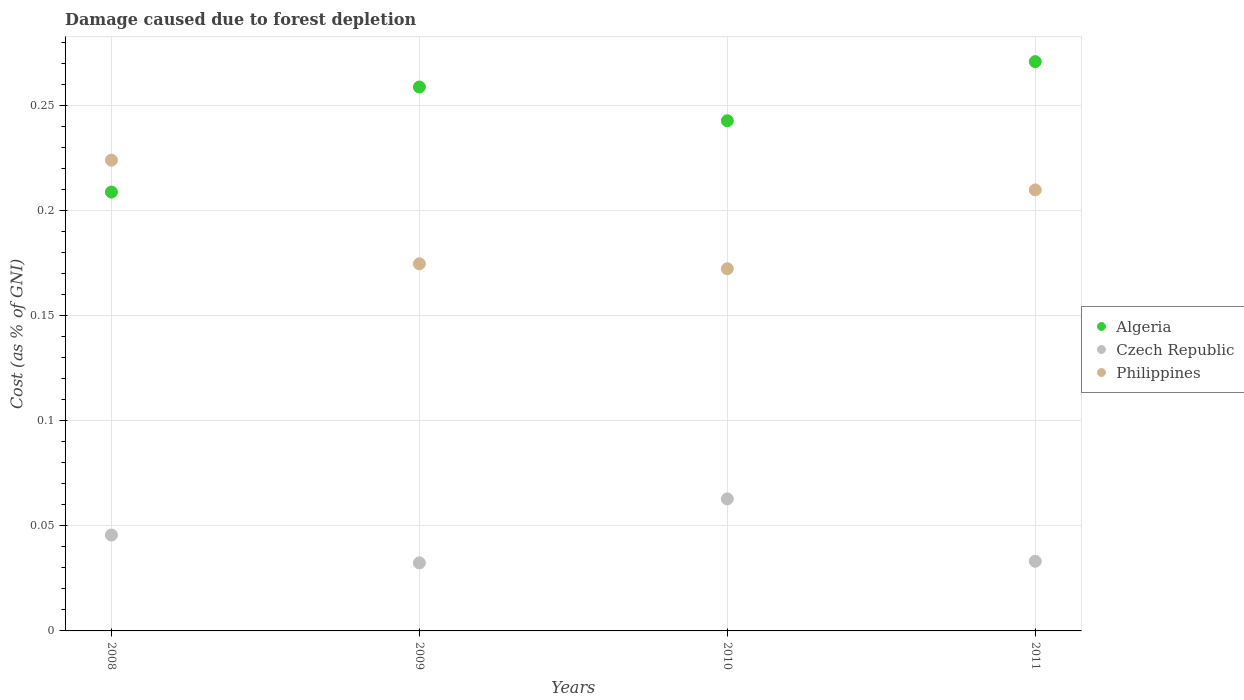How many different coloured dotlines are there?
Make the answer very short. 3. What is the cost of damage caused due to forest depletion in Algeria in 2010?
Your answer should be very brief. 0.24. Across all years, what is the maximum cost of damage caused due to forest depletion in Philippines?
Ensure brevity in your answer.  0.22. Across all years, what is the minimum cost of damage caused due to forest depletion in Algeria?
Offer a terse response. 0.21. In which year was the cost of damage caused due to forest depletion in Algeria maximum?
Provide a succinct answer. 2011. What is the total cost of damage caused due to forest depletion in Algeria in the graph?
Your answer should be very brief. 0.98. What is the difference between the cost of damage caused due to forest depletion in Algeria in 2009 and that in 2010?
Provide a short and direct response. 0.02. What is the difference between the cost of damage caused due to forest depletion in Czech Republic in 2009 and the cost of damage caused due to forest depletion in Philippines in 2010?
Offer a terse response. -0.14. What is the average cost of damage caused due to forest depletion in Czech Republic per year?
Offer a very short reply. 0.04. In the year 2010, what is the difference between the cost of damage caused due to forest depletion in Algeria and cost of damage caused due to forest depletion in Czech Republic?
Provide a succinct answer. 0.18. In how many years, is the cost of damage caused due to forest depletion in Czech Republic greater than 0.26 %?
Keep it short and to the point. 0. What is the ratio of the cost of damage caused due to forest depletion in Philippines in 2010 to that in 2011?
Your answer should be very brief. 0.82. Is the cost of damage caused due to forest depletion in Czech Republic in 2009 less than that in 2010?
Provide a succinct answer. Yes. Is the difference between the cost of damage caused due to forest depletion in Algeria in 2009 and 2011 greater than the difference between the cost of damage caused due to forest depletion in Czech Republic in 2009 and 2011?
Your answer should be compact. No. What is the difference between the highest and the second highest cost of damage caused due to forest depletion in Czech Republic?
Offer a terse response. 0.02. What is the difference between the highest and the lowest cost of damage caused due to forest depletion in Philippines?
Your answer should be very brief. 0.05. Is the sum of the cost of damage caused due to forest depletion in Philippines in 2009 and 2011 greater than the maximum cost of damage caused due to forest depletion in Algeria across all years?
Keep it short and to the point. Yes. Is it the case that in every year, the sum of the cost of damage caused due to forest depletion in Philippines and cost of damage caused due to forest depletion in Czech Republic  is greater than the cost of damage caused due to forest depletion in Algeria?
Keep it short and to the point. No. Does the cost of damage caused due to forest depletion in Czech Republic monotonically increase over the years?
Offer a terse response. No. How many dotlines are there?
Give a very brief answer. 3. How many years are there in the graph?
Give a very brief answer. 4. What is the difference between two consecutive major ticks on the Y-axis?
Your answer should be compact. 0.05. Are the values on the major ticks of Y-axis written in scientific E-notation?
Give a very brief answer. No. Does the graph contain grids?
Provide a succinct answer. Yes. Where does the legend appear in the graph?
Make the answer very short. Center right. What is the title of the graph?
Your response must be concise. Damage caused due to forest depletion. Does "Puerto Rico" appear as one of the legend labels in the graph?
Your response must be concise. No. What is the label or title of the X-axis?
Keep it short and to the point. Years. What is the label or title of the Y-axis?
Your answer should be very brief. Cost (as % of GNI). What is the Cost (as % of GNI) of Algeria in 2008?
Ensure brevity in your answer.  0.21. What is the Cost (as % of GNI) of Czech Republic in 2008?
Your answer should be compact. 0.05. What is the Cost (as % of GNI) in Philippines in 2008?
Provide a short and direct response. 0.22. What is the Cost (as % of GNI) of Algeria in 2009?
Your response must be concise. 0.26. What is the Cost (as % of GNI) of Czech Republic in 2009?
Provide a succinct answer. 0.03. What is the Cost (as % of GNI) in Philippines in 2009?
Provide a succinct answer. 0.17. What is the Cost (as % of GNI) of Algeria in 2010?
Provide a short and direct response. 0.24. What is the Cost (as % of GNI) in Czech Republic in 2010?
Your answer should be compact. 0.06. What is the Cost (as % of GNI) of Philippines in 2010?
Provide a succinct answer. 0.17. What is the Cost (as % of GNI) of Algeria in 2011?
Your answer should be compact. 0.27. What is the Cost (as % of GNI) in Czech Republic in 2011?
Your answer should be very brief. 0.03. What is the Cost (as % of GNI) of Philippines in 2011?
Your response must be concise. 0.21. Across all years, what is the maximum Cost (as % of GNI) in Algeria?
Offer a terse response. 0.27. Across all years, what is the maximum Cost (as % of GNI) in Czech Republic?
Your answer should be compact. 0.06. Across all years, what is the maximum Cost (as % of GNI) in Philippines?
Make the answer very short. 0.22. Across all years, what is the minimum Cost (as % of GNI) of Algeria?
Your answer should be compact. 0.21. Across all years, what is the minimum Cost (as % of GNI) in Czech Republic?
Your answer should be compact. 0.03. Across all years, what is the minimum Cost (as % of GNI) of Philippines?
Offer a very short reply. 0.17. What is the total Cost (as % of GNI) in Algeria in the graph?
Provide a short and direct response. 0.98. What is the total Cost (as % of GNI) in Czech Republic in the graph?
Ensure brevity in your answer.  0.17. What is the total Cost (as % of GNI) of Philippines in the graph?
Provide a succinct answer. 0.78. What is the difference between the Cost (as % of GNI) in Czech Republic in 2008 and that in 2009?
Your response must be concise. 0.01. What is the difference between the Cost (as % of GNI) in Philippines in 2008 and that in 2009?
Your response must be concise. 0.05. What is the difference between the Cost (as % of GNI) in Algeria in 2008 and that in 2010?
Make the answer very short. -0.03. What is the difference between the Cost (as % of GNI) of Czech Republic in 2008 and that in 2010?
Offer a terse response. -0.02. What is the difference between the Cost (as % of GNI) of Philippines in 2008 and that in 2010?
Offer a terse response. 0.05. What is the difference between the Cost (as % of GNI) of Algeria in 2008 and that in 2011?
Your answer should be very brief. -0.06. What is the difference between the Cost (as % of GNI) in Czech Republic in 2008 and that in 2011?
Ensure brevity in your answer.  0.01. What is the difference between the Cost (as % of GNI) in Philippines in 2008 and that in 2011?
Provide a short and direct response. 0.01. What is the difference between the Cost (as % of GNI) of Algeria in 2009 and that in 2010?
Your answer should be compact. 0.02. What is the difference between the Cost (as % of GNI) of Czech Republic in 2009 and that in 2010?
Provide a short and direct response. -0.03. What is the difference between the Cost (as % of GNI) of Philippines in 2009 and that in 2010?
Your answer should be very brief. 0. What is the difference between the Cost (as % of GNI) of Algeria in 2009 and that in 2011?
Offer a very short reply. -0.01. What is the difference between the Cost (as % of GNI) in Czech Republic in 2009 and that in 2011?
Offer a terse response. -0. What is the difference between the Cost (as % of GNI) in Philippines in 2009 and that in 2011?
Make the answer very short. -0.04. What is the difference between the Cost (as % of GNI) in Algeria in 2010 and that in 2011?
Give a very brief answer. -0.03. What is the difference between the Cost (as % of GNI) of Czech Republic in 2010 and that in 2011?
Offer a very short reply. 0.03. What is the difference between the Cost (as % of GNI) of Philippines in 2010 and that in 2011?
Your response must be concise. -0.04. What is the difference between the Cost (as % of GNI) of Algeria in 2008 and the Cost (as % of GNI) of Czech Republic in 2009?
Provide a short and direct response. 0.18. What is the difference between the Cost (as % of GNI) of Algeria in 2008 and the Cost (as % of GNI) of Philippines in 2009?
Your answer should be very brief. 0.03. What is the difference between the Cost (as % of GNI) of Czech Republic in 2008 and the Cost (as % of GNI) of Philippines in 2009?
Your response must be concise. -0.13. What is the difference between the Cost (as % of GNI) of Algeria in 2008 and the Cost (as % of GNI) of Czech Republic in 2010?
Your response must be concise. 0.15. What is the difference between the Cost (as % of GNI) in Algeria in 2008 and the Cost (as % of GNI) in Philippines in 2010?
Keep it short and to the point. 0.04. What is the difference between the Cost (as % of GNI) of Czech Republic in 2008 and the Cost (as % of GNI) of Philippines in 2010?
Your answer should be very brief. -0.13. What is the difference between the Cost (as % of GNI) in Algeria in 2008 and the Cost (as % of GNI) in Czech Republic in 2011?
Offer a very short reply. 0.18. What is the difference between the Cost (as % of GNI) in Algeria in 2008 and the Cost (as % of GNI) in Philippines in 2011?
Offer a very short reply. -0. What is the difference between the Cost (as % of GNI) in Czech Republic in 2008 and the Cost (as % of GNI) in Philippines in 2011?
Make the answer very short. -0.16. What is the difference between the Cost (as % of GNI) of Algeria in 2009 and the Cost (as % of GNI) of Czech Republic in 2010?
Provide a short and direct response. 0.2. What is the difference between the Cost (as % of GNI) in Algeria in 2009 and the Cost (as % of GNI) in Philippines in 2010?
Give a very brief answer. 0.09. What is the difference between the Cost (as % of GNI) in Czech Republic in 2009 and the Cost (as % of GNI) in Philippines in 2010?
Give a very brief answer. -0.14. What is the difference between the Cost (as % of GNI) of Algeria in 2009 and the Cost (as % of GNI) of Czech Republic in 2011?
Make the answer very short. 0.23. What is the difference between the Cost (as % of GNI) in Algeria in 2009 and the Cost (as % of GNI) in Philippines in 2011?
Provide a succinct answer. 0.05. What is the difference between the Cost (as % of GNI) of Czech Republic in 2009 and the Cost (as % of GNI) of Philippines in 2011?
Your response must be concise. -0.18. What is the difference between the Cost (as % of GNI) in Algeria in 2010 and the Cost (as % of GNI) in Czech Republic in 2011?
Offer a terse response. 0.21. What is the difference between the Cost (as % of GNI) in Algeria in 2010 and the Cost (as % of GNI) in Philippines in 2011?
Your answer should be very brief. 0.03. What is the difference between the Cost (as % of GNI) in Czech Republic in 2010 and the Cost (as % of GNI) in Philippines in 2011?
Give a very brief answer. -0.15. What is the average Cost (as % of GNI) in Algeria per year?
Make the answer very short. 0.25. What is the average Cost (as % of GNI) of Czech Republic per year?
Your answer should be compact. 0.04. What is the average Cost (as % of GNI) in Philippines per year?
Make the answer very short. 0.2. In the year 2008, what is the difference between the Cost (as % of GNI) of Algeria and Cost (as % of GNI) of Czech Republic?
Your answer should be compact. 0.16. In the year 2008, what is the difference between the Cost (as % of GNI) in Algeria and Cost (as % of GNI) in Philippines?
Make the answer very short. -0.02. In the year 2008, what is the difference between the Cost (as % of GNI) of Czech Republic and Cost (as % of GNI) of Philippines?
Offer a terse response. -0.18. In the year 2009, what is the difference between the Cost (as % of GNI) in Algeria and Cost (as % of GNI) in Czech Republic?
Ensure brevity in your answer.  0.23. In the year 2009, what is the difference between the Cost (as % of GNI) in Algeria and Cost (as % of GNI) in Philippines?
Your response must be concise. 0.08. In the year 2009, what is the difference between the Cost (as % of GNI) of Czech Republic and Cost (as % of GNI) of Philippines?
Your response must be concise. -0.14. In the year 2010, what is the difference between the Cost (as % of GNI) of Algeria and Cost (as % of GNI) of Czech Republic?
Your response must be concise. 0.18. In the year 2010, what is the difference between the Cost (as % of GNI) in Algeria and Cost (as % of GNI) in Philippines?
Make the answer very short. 0.07. In the year 2010, what is the difference between the Cost (as % of GNI) of Czech Republic and Cost (as % of GNI) of Philippines?
Your answer should be very brief. -0.11. In the year 2011, what is the difference between the Cost (as % of GNI) of Algeria and Cost (as % of GNI) of Czech Republic?
Give a very brief answer. 0.24. In the year 2011, what is the difference between the Cost (as % of GNI) of Algeria and Cost (as % of GNI) of Philippines?
Provide a succinct answer. 0.06. In the year 2011, what is the difference between the Cost (as % of GNI) of Czech Republic and Cost (as % of GNI) of Philippines?
Ensure brevity in your answer.  -0.18. What is the ratio of the Cost (as % of GNI) in Algeria in 2008 to that in 2009?
Your answer should be very brief. 0.81. What is the ratio of the Cost (as % of GNI) of Czech Republic in 2008 to that in 2009?
Make the answer very short. 1.41. What is the ratio of the Cost (as % of GNI) in Philippines in 2008 to that in 2009?
Give a very brief answer. 1.28. What is the ratio of the Cost (as % of GNI) of Algeria in 2008 to that in 2010?
Provide a short and direct response. 0.86. What is the ratio of the Cost (as % of GNI) of Czech Republic in 2008 to that in 2010?
Keep it short and to the point. 0.73. What is the ratio of the Cost (as % of GNI) of Philippines in 2008 to that in 2010?
Your answer should be very brief. 1.3. What is the ratio of the Cost (as % of GNI) of Algeria in 2008 to that in 2011?
Your answer should be compact. 0.77. What is the ratio of the Cost (as % of GNI) in Czech Republic in 2008 to that in 2011?
Your answer should be compact. 1.38. What is the ratio of the Cost (as % of GNI) in Philippines in 2008 to that in 2011?
Provide a succinct answer. 1.07. What is the ratio of the Cost (as % of GNI) in Algeria in 2009 to that in 2010?
Ensure brevity in your answer.  1.07. What is the ratio of the Cost (as % of GNI) in Czech Republic in 2009 to that in 2010?
Your answer should be compact. 0.52. What is the ratio of the Cost (as % of GNI) of Philippines in 2009 to that in 2010?
Your response must be concise. 1.01. What is the ratio of the Cost (as % of GNI) in Algeria in 2009 to that in 2011?
Offer a very short reply. 0.96. What is the ratio of the Cost (as % of GNI) of Czech Republic in 2009 to that in 2011?
Provide a succinct answer. 0.98. What is the ratio of the Cost (as % of GNI) in Philippines in 2009 to that in 2011?
Keep it short and to the point. 0.83. What is the ratio of the Cost (as % of GNI) in Algeria in 2010 to that in 2011?
Offer a terse response. 0.9. What is the ratio of the Cost (as % of GNI) of Czech Republic in 2010 to that in 2011?
Your answer should be compact. 1.9. What is the ratio of the Cost (as % of GNI) in Philippines in 2010 to that in 2011?
Offer a terse response. 0.82. What is the difference between the highest and the second highest Cost (as % of GNI) of Algeria?
Offer a terse response. 0.01. What is the difference between the highest and the second highest Cost (as % of GNI) in Czech Republic?
Your answer should be very brief. 0.02. What is the difference between the highest and the second highest Cost (as % of GNI) of Philippines?
Provide a succinct answer. 0.01. What is the difference between the highest and the lowest Cost (as % of GNI) of Algeria?
Offer a terse response. 0.06. What is the difference between the highest and the lowest Cost (as % of GNI) in Czech Republic?
Offer a very short reply. 0.03. What is the difference between the highest and the lowest Cost (as % of GNI) in Philippines?
Provide a succinct answer. 0.05. 